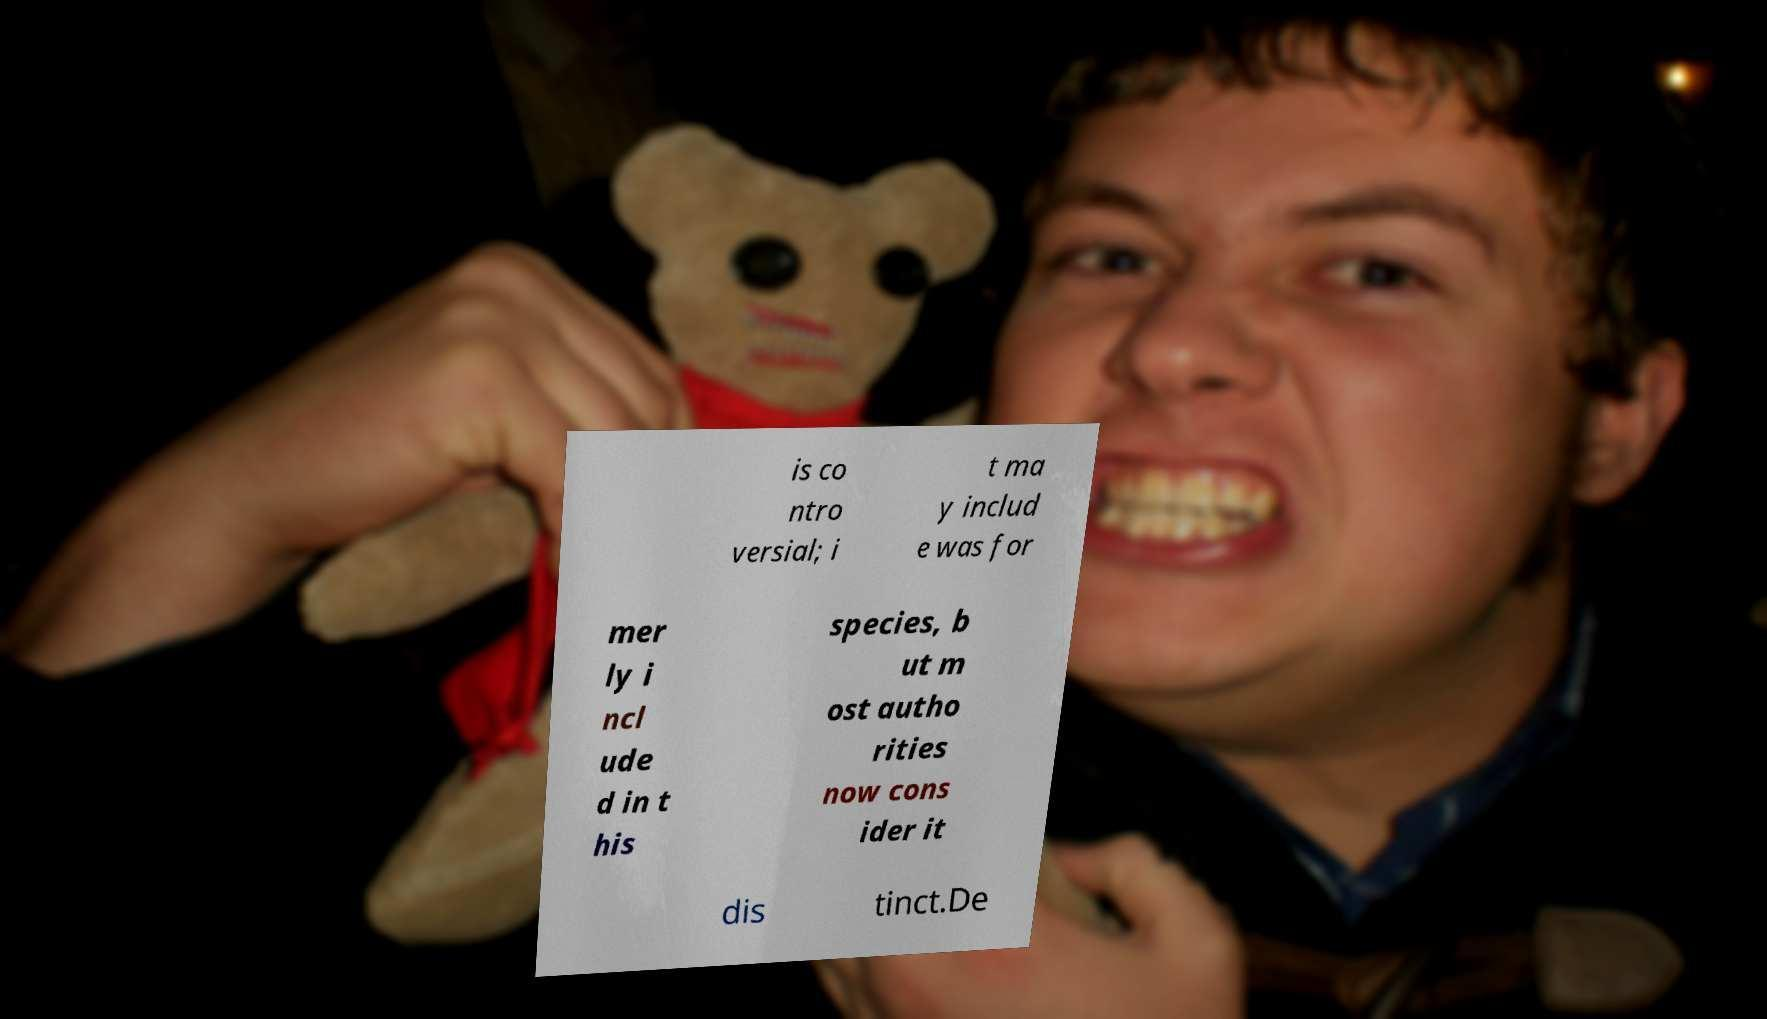Could you assist in decoding the text presented in this image and type it out clearly? is co ntro versial; i t ma y includ e was for mer ly i ncl ude d in t his species, b ut m ost autho rities now cons ider it dis tinct.De 